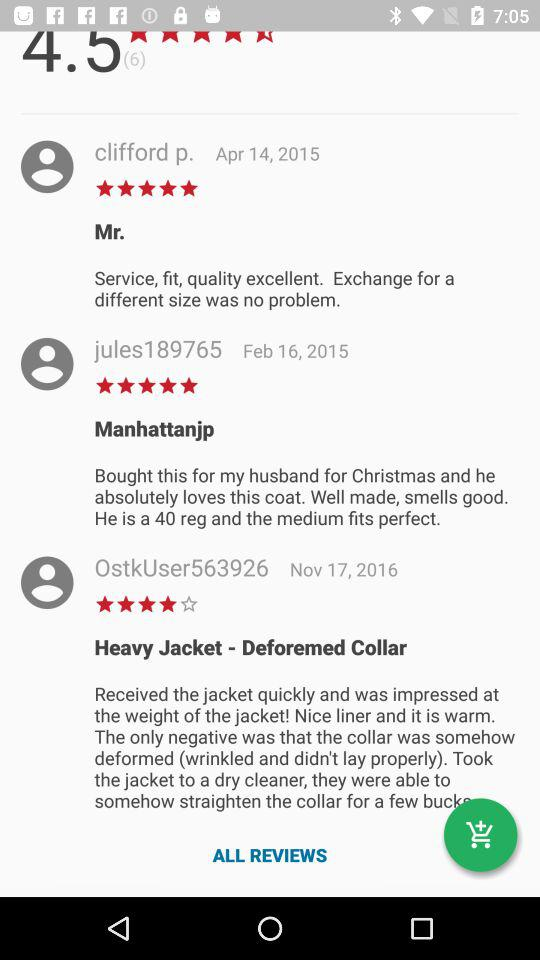How many reviews are there for this item?
Answer the question using a single word or phrase. 6 